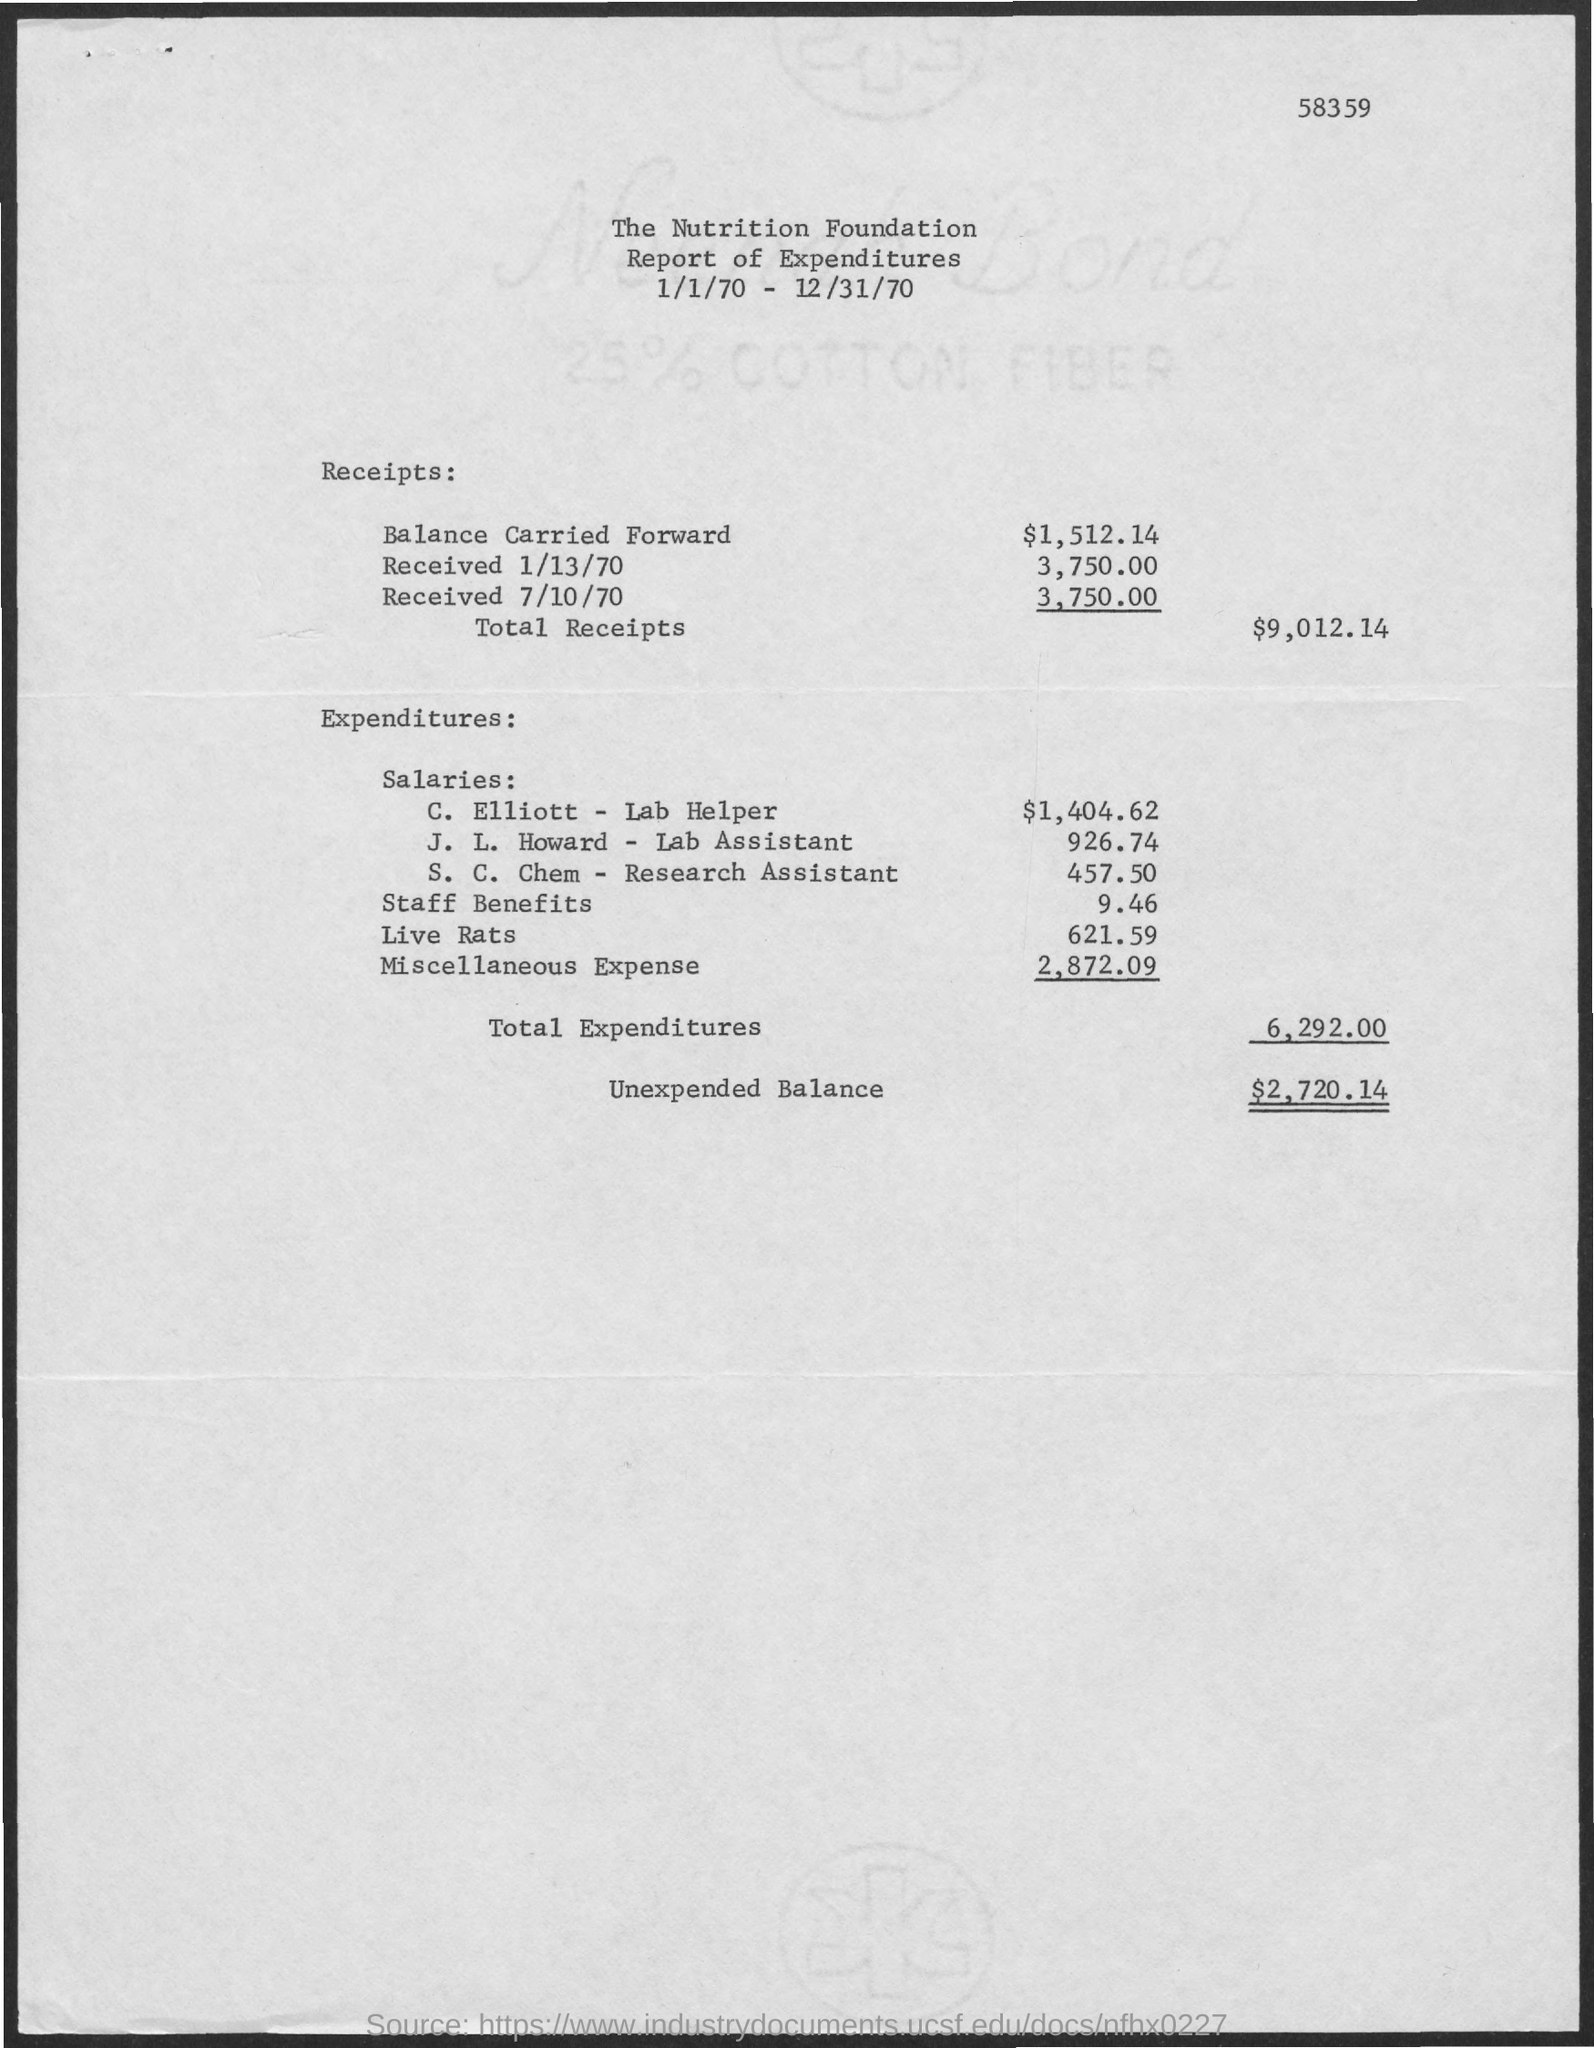Outline some significant characteristics in this image. On July 10th, 1970, the amount received was $3,750.00. The amount of miscellaneous expenses mentioned in the given report is $2,872.09. The total amount of receipts mentioned in the given report is $9,012.14. The salary given to C. Elliott, a labor helper, is $1,404.62. The unexpended balance mentioned in the given report is $2,720.14. 